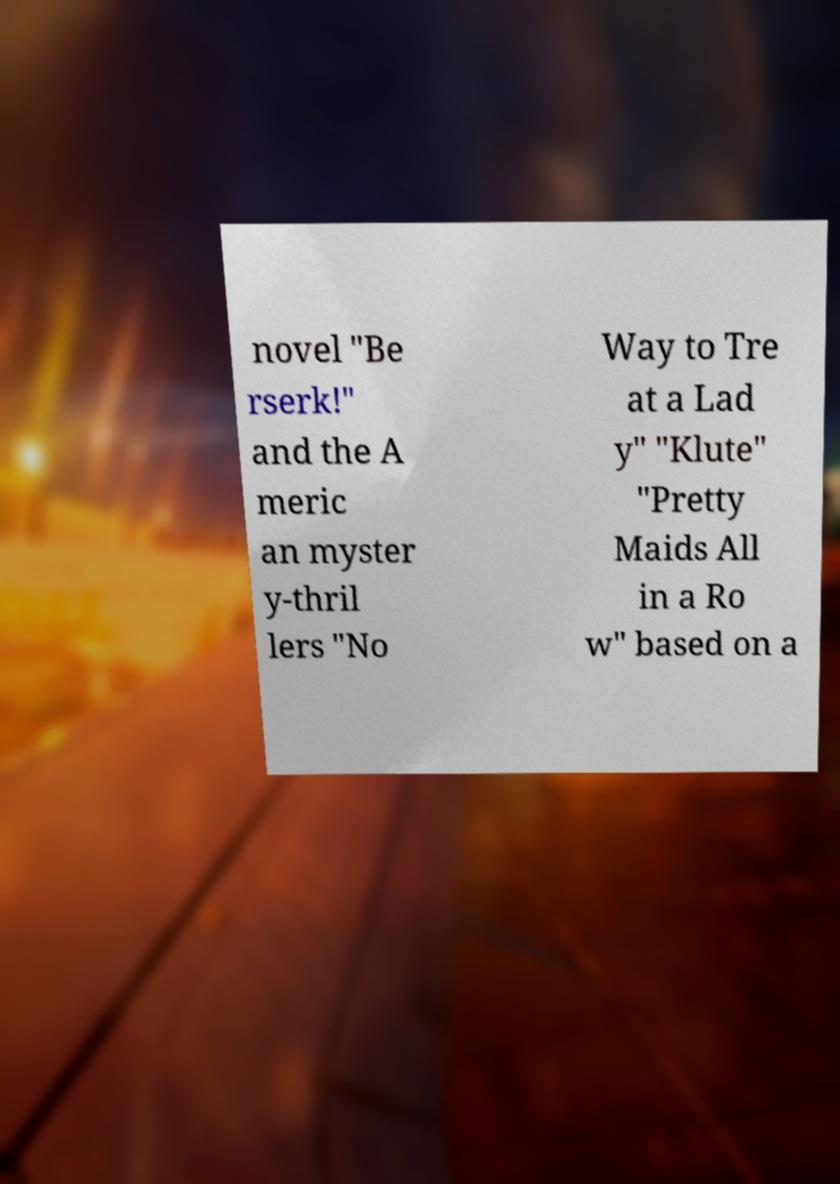Can you read and provide the text displayed in the image?This photo seems to have some interesting text. Can you extract and type it out for me? novel "Be rserk!" and the A meric an myster y-thril lers "No Way to Tre at a Lad y" "Klute" "Pretty Maids All in a Ro w" based on a 